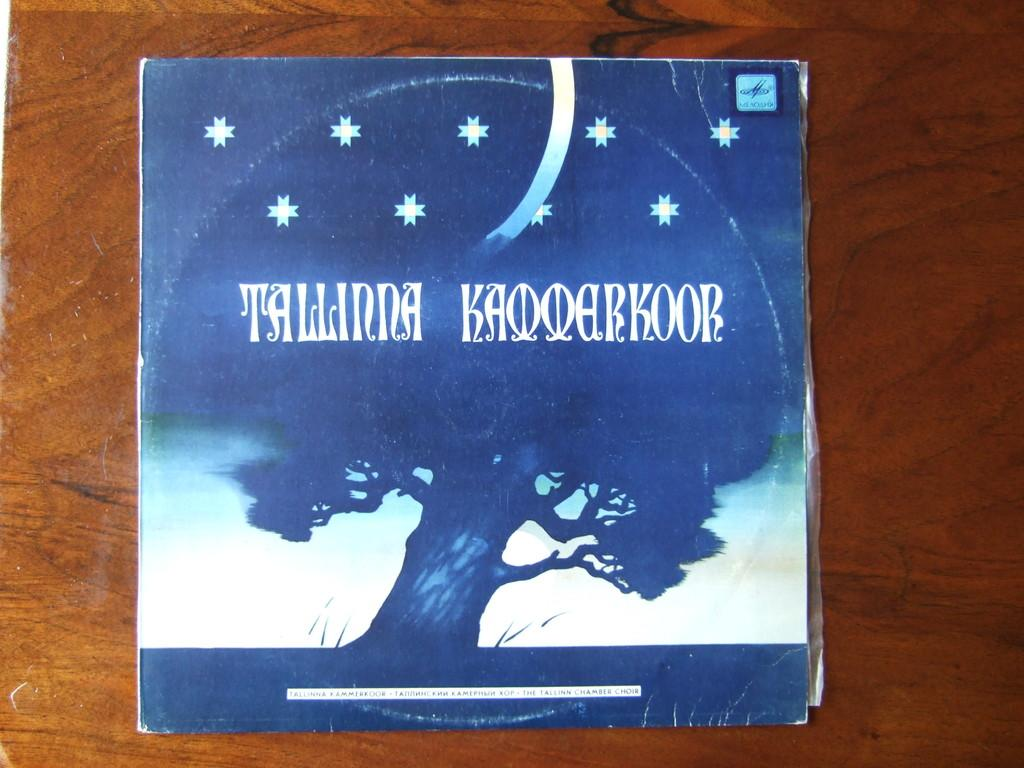<image>
Describe the image concisely. A  blue and white album cover with the word Talinna Kaooarkoor printed on the front. 